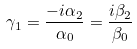<formula> <loc_0><loc_0><loc_500><loc_500>\gamma _ { 1 } = \frac { - i \alpha _ { 2 } } { \alpha _ { 0 } } = \frac { i \beta _ { 2 } } { \beta _ { 0 } }</formula> 